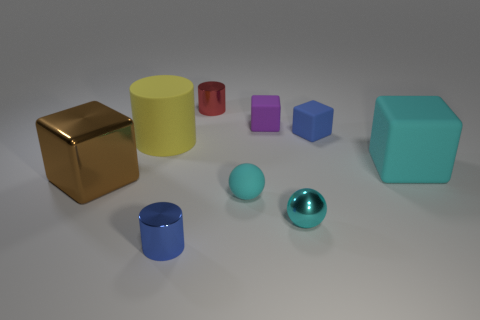Subtract all shiny cylinders. How many cylinders are left? 1 Subtract all cyan cubes. How many cubes are left? 3 Add 1 small metal cylinders. How many objects exist? 10 Subtract all yellow blocks. Subtract all yellow balls. How many blocks are left? 4 Subtract all balls. How many objects are left? 7 Subtract all metal spheres. Subtract all purple objects. How many objects are left? 7 Add 6 purple things. How many purple things are left? 7 Add 4 small cyan metallic objects. How many small cyan metallic objects exist? 5 Subtract 0 gray blocks. How many objects are left? 9 